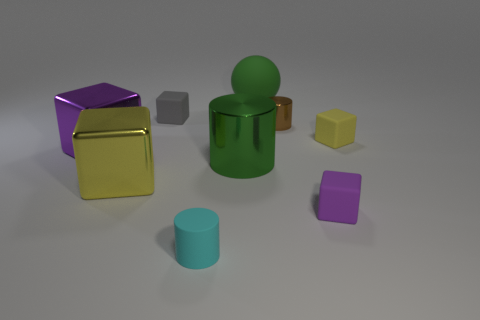How big is the purple object that is to the left of the gray rubber cube that is behind the green shiny cylinder?
Your answer should be very brief. Large. What color is the matte block that is both to the left of the yellow rubber thing and behind the yellow metallic cube?
Keep it short and to the point. Gray. There is a purple object that is the same size as the ball; what material is it?
Ensure brevity in your answer.  Metal. What number of other objects are the same material as the tiny purple cube?
Offer a terse response. 4. Is the color of the large cube behind the big metallic cylinder the same as the large metallic thing right of the small gray thing?
Provide a succinct answer. No. There is a yellow object to the right of the yellow block that is left of the large green matte object; what shape is it?
Your response must be concise. Cube. How many other objects are there of the same color as the big metallic cylinder?
Offer a terse response. 1. Do the yellow thing to the left of the large green rubber object and the yellow block right of the ball have the same material?
Your response must be concise. No. There is a shiny cylinder that is in front of the tiny yellow cube; how big is it?
Ensure brevity in your answer.  Large. There is a green thing that is the same shape as the brown thing; what is it made of?
Give a very brief answer. Metal. 